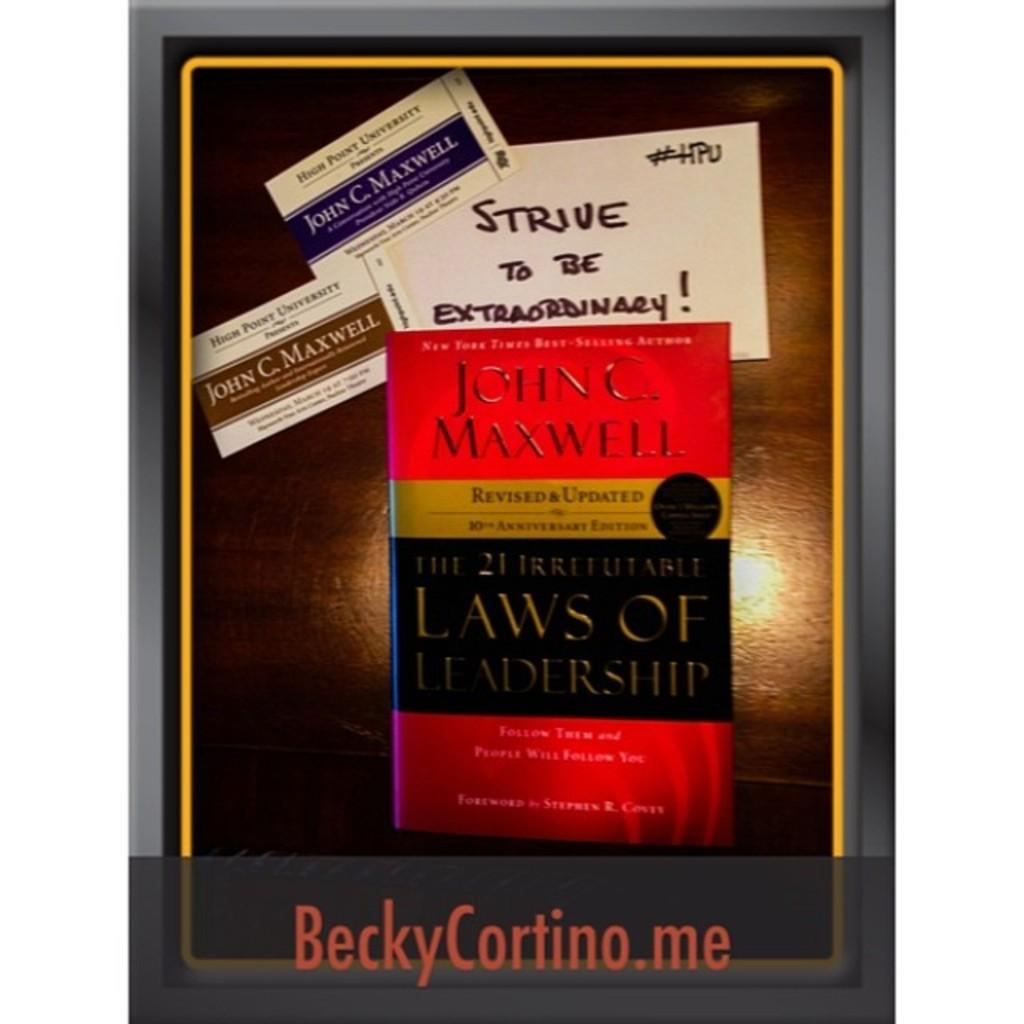What is the book title?
Provide a succinct answer. Laws of leadership. 